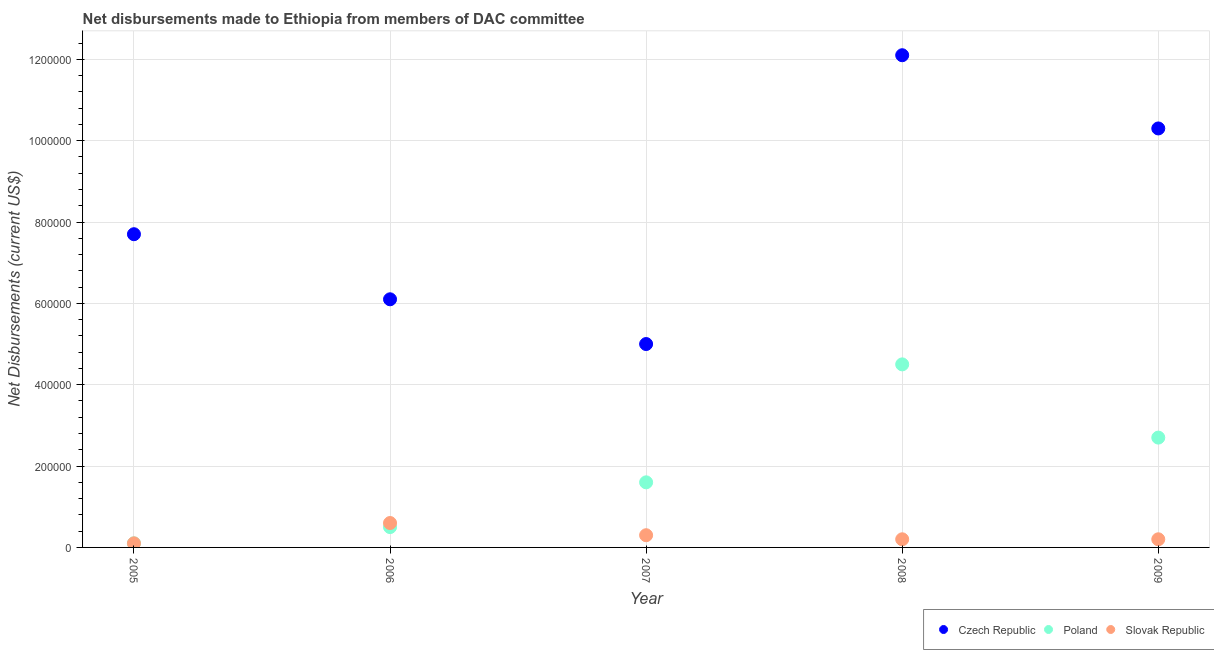What is the net disbursements made by czech republic in 2006?
Offer a very short reply. 6.10e+05. Across all years, what is the maximum net disbursements made by slovak republic?
Make the answer very short. 6.00e+04. Across all years, what is the minimum net disbursements made by slovak republic?
Offer a very short reply. 10000. In which year was the net disbursements made by poland minimum?
Provide a succinct answer. 2005. What is the total net disbursements made by poland in the graph?
Offer a terse response. 9.40e+05. What is the difference between the net disbursements made by czech republic in 2006 and that in 2007?
Provide a short and direct response. 1.10e+05. What is the difference between the net disbursements made by slovak republic in 2007 and the net disbursements made by poland in 2008?
Your response must be concise. -4.20e+05. What is the average net disbursements made by slovak republic per year?
Provide a short and direct response. 2.80e+04. In the year 2006, what is the difference between the net disbursements made by slovak republic and net disbursements made by poland?
Your answer should be very brief. 10000. What is the ratio of the net disbursements made by poland in 2007 to that in 2008?
Provide a short and direct response. 0.36. What is the difference between the highest and the second highest net disbursements made by czech republic?
Offer a terse response. 1.80e+05. What is the difference between the highest and the lowest net disbursements made by czech republic?
Offer a very short reply. 7.10e+05. How many dotlines are there?
Make the answer very short. 3. What is the difference between two consecutive major ticks on the Y-axis?
Your answer should be very brief. 2.00e+05. How many legend labels are there?
Make the answer very short. 3. What is the title of the graph?
Your response must be concise. Net disbursements made to Ethiopia from members of DAC committee. Does "Agricultural Nitrous Oxide" appear as one of the legend labels in the graph?
Keep it short and to the point. No. What is the label or title of the X-axis?
Provide a short and direct response. Year. What is the label or title of the Y-axis?
Offer a terse response. Net Disbursements (current US$). What is the Net Disbursements (current US$) of Czech Republic in 2005?
Your response must be concise. 7.70e+05. What is the Net Disbursements (current US$) of Poland in 2005?
Your response must be concise. 10000. What is the Net Disbursements (current US$) in Czech Republic in 2006?
Offer a terse response. 6.10e+05. What is the Net Disbursements (current US$) of Poland in 2006?
Provide a short and direct response. 5.00e+04. What is the Net Disbursements (current US$) in Czech Republic in 2008?
Provide a succinct answer. 1.21e+06. What is the Net Disbursements (current US$) of Czech Republic in 2009?
Your answer should be compact. 1.03e+06. What is the Net Disbursements (current US$) of Poland in 2009?
Provide a succinct answer. 2.70e+05. Across all years, what is the maximum Net Disbursements (current US$) in Czech Republic?
Your answer should be very brief. 1.21e+06. Across all years, what is the maximum Net Disbursements (current US$) in Poland?
Provide a short and direct response. 4.50e+05. Across all years, what is the maximum Net Disbursements (current US$) in Slovak Republic?
Offer a terse response. 6.00e+04. Across all years, what is the minimum Net Disbursements (current US$) of Czech Republic?
Make the answer very short. 5.00e+05. Across all years, what is the minimum Net Disbursements (current US$) of Poland?
Offer a very short reply. 10000. Across all years, what is the minimum Net Disbursements (current US$) of Slovak Republic?
Your answer should be compact. 10000. What is the total Net Disbursements (current US$) in Czech Republic in the graph?
Your answer should be compact. 4.12e+06. What is the total Net Disbursements (current US$) of Poland in the graph?
Provide a short and direct response. 9.40e+05. What is the total Net Disbursements (current US$) of Slovak Republic in the graph?
Your response must be concise. 1.40e+05. What is the difference between the Net Disbursements (current US$) of Slovak Republic in 2005 and that in 2006?
Keep it short and to the point. -5.00e+04. What is the difference between the Net Disbursements (current US$) in Czech Republic in 2005 and that in 2007?
Give a very brief answer. 2.70e+05. What is the difference between the Net Disbursements (current US$) in Poland in 2005 and that in 2007?
Make the answer very short. -1.50e+05. What is the difference between the Net Disbursements (current US$) in Slovak Republic in 2005 and that in 2007?
Make the answer very short. -2.00e+04. What is the difference between the Net Disbursements (current US$) in Czech Republic in 2005 and that in 2008?
Provide a short and direct response. -4.40e+05. What is the difference between the Net Disbursements (current US$) of Poland in 2005 and that in 2008?
Offer a terse response. -4.40e+05. What is the difference between the Net Disbursements (current US$) in Czech Republic in 2005 and that in 2009?
Offer a terse response. -2.60e+05. What is the difference between the Net Disbursements (current US$) in Poland in 2006 and that in 2007?
Provide a short and direct response. -1.10e+05. What is the difference between the Net Disbursements (current US$) of Slovak Republic in 2006 and that in 2007?
Offer a terse response. 3.00e+04. What is the difference between the Net Disbursements (current US$) of Czech Republic in 2006 and that in 2008?
Keep it short and to the point. -6.00e+05. What is the difference between the Net Disbursements (current US$) of Poland in 2006 and that in 2008?
Make the answer very short. -4.00e+05. What is the difference between the Net Disbursements (current US$) in Czech Republic in 2006 and that in 2009?
Provide a short and direct response. -4.20e+05. What is the difference between the Net Disbursements (current US$) in Poland in 2006 and that in 2009?
Make the answer very short. -2.20e+05. What is the difference between the Net Disbursements (current US$) of Czech Republic in 2007 and that in 2008?
Offer a terse response. -7.10e+05. What is the difference between the Net Disbursements (current US$) in Czech Republic in 2007 and that in 2009?
Make the answer very short. -5.30e+05. What is the difference between the Net Disbursements (current US$) of Poland in 2007 and that in 2009?
Ensure brevity in your answer.  -1.10e+05. What is the difference between the Net Disbursements (current US$) of Slovak Republic in 2007 and that in 2009?
Ensure brevity in your answer.  10000. What is the difference between the Net Disbursements (current US$) of Slovak Republic in 2008 and that in 2009?
Offer a terse response. 0. What is the difference between the Net Disbursements (current US$) in Czech Republic in 2005 and the Net Disbursements (current US$) in Poland in 2006?
Offer a terse response. 7.20e+05. What is the difference between the Net Disbursements (current US$) in Czech Republic in 2005 and the Net Disbursements (current US$) in Slovak Republic in 2006?
Give a very brief answer. 7.10e+05. What is the difference between the Net Disbursements (current US$) of Czech Republic in 2005 and the Net Disbursements (current US$) of Slovak Republic in 2007?
Provide a short and direct response. 7.40e+05. What is the difference between the Net Disbursements (current US$) of Poland in 2005 and the Net Disbursements (current US$) of Slovak Republic in 2007?
Make the answer very short. -2.00e+04. What is the difference between the Net Disbursements (current US$) of Czech Republic in 2005 and the Net Disbursements (current US$) of Poland in 2008?
Your answer should be very brief. 3.20e+05. What is the difference between the Net Disbursements (current US$) of Czech Republic in 2005 and the Net Disbursements (current US$) of Slovak Republic in 2008?
Offer a very short reply. 7.50e+05. What is the difference between the Net Disbursements (current US$) in Czech Republic in 2005 and the Net Disbursements (current US$) in Slovak Republic in 2009?
Offer a very short reply. 7.50e+05. What is the difference between the Net Disbursements (current US$) in Czech Republic in 2006 and the Net Disbursements (current US$) in Poland in 2007?
Make the answer very short. 4.50e+05. What is the difference between the Net Disbursements (current US$) of Czech Republic in 2006 and the Net Disbursements (current US$) of Slovak Republic in 2007?
Provide a succinct answer. 5.80e+05. What is the difference between the Net Disbursements (current US$) of Poland in 2006 and the Net Disbursements (current US$) of Slovak Republic in 2007?
Your answer should be very brief. 2.00e+04. What is the difference between the Net Disbursements (current US$) of Czech Republic in 2006 and the Net Disbursements (current US$) of Poland in 2008?
Offer a terse response. 1.60e+05. What is the difference between the Net Disbursements (current US$) of Czech Republic in 2006 and the Net Disbursements (current US$) of Slovak Republic in 2008?
Offer a terse response. 5.90e+05. What is the difference between the Net Disbursements (current US$) in Czech Republic in 2006 and the Net Disbursements (current US$) in Slovak Republic in 2009?
Your answer should be compact. 5.90e+05. What is the difference between the Net Disbursements (current US$) in Poland in 2006 and the Net Disbursements (current US$) in Slovak Republic in 2009?
Your answer should be compact. 3.00e+04. What is the difference between the Net Disbursements (current US$) of Czech Republic in 2007 and the Net Disbursements (current US$) of Slovak Republic in 2008?
Keep it short and to the point. 4.80e+05. What is the difference between the Net Disbursements (current US$) of Czech Republic in 2007 and the Net Disbursements (current US$) of Poland in 2009?
Your response must be concise. 2.30e+05. What is the difference between the Net Disbursements (current US$) of Czech Republic in 2008 and the Net Disbursements (current US$) of Poland in 2009?
Make the answer very short. 9.40e+05. What is the difference between the Net Disbursements (current US$) of Czech Republic in 2008 and the Net Disbursements (current US$) of Slovak Republic in 2009?
Provide a short and direct response. 1.19e+06. What is the average Net Disbursements (current US$) of Czech Republic per year?
Provide a succinct answer. 8.24e+05. What is the average Net Disbursements (current US$) of Poland per year?
Offer a very short reply. 1.88e+05. What is the average Net Disbursements (current US$) of Slovak Republic per year?
Keep it short and to the point. 2.80e+04. In the year 2005, what is the difference between the Net Disbursements (current US$) of Czech Republic and Net Disbursements (current US$) of Poland?
Your answer should be very brief. 7.60e+05. In the year 2005, what is the difference between the Net Disbursements (current US$) of Czech Republic and Net Disbursements (current US$) of Slovak Republic?
Keep it short and to the point. 7.60e+05. In the year 2006, what is the difference between the Net Disbursements (current US$) in Czech Republic and Net Disbursements (current US$) in Poland?
Provide a succinct answer. 5.60e+05. In the year 2006, what is the difference between the Net Disbursements (current US$) of Poland and Net Disbursements (current US$) of Slovak Republic?
Ensure brevity in your answer.  -10000. In the year 2008, what is the difference between the Net Disbursements (current US$) of Czech Republic and Net Disbursements (current US$) of Poland?
Provide a succinct answer. 7.60e+05. In the year 2008, what is the difference between the Net Disbursements (current US$) in Czech Republic and Net Disbursements (current US$) in Slovak Republic?
Ensure brevity in your answer.  1.19e+06. In the year 2008, what is the difference between the Net Disbursements (current US$) of Poland and Net Disbursements (current US$) of Slovak Republic?
Make the answer very short. 4.30e+05. In the year 2009, what is the difference between the Net Disbursements (current US$) in Czech Republic and Net Disbursements (current US$) in Poland?
Give a very brief answer. 7.60e+05. In the year 2009, what is the difference between the Net Disbursements (current US$) of Czech Republic and Net Disbursements (current US$) of Slovak Republic?
Your response must be concise. 1.01e+06. In the year 2009, what is the difference between the Net Disbursements (current US$) in Poland and Net Disbursements (current US$) in Slovak Republic?
Provide a succinct answer. 2.50e+05. What is the ratio of the Net Disbursements (current US$) in Czech Republic in 2005 to that in 2006?
Offer a terse response. 1.26. What is the ratio of the Net Disbursements (current US$) of Poland in 2005 to that in 2006?
Give a very brief answer. 0.2. What is the ratio of the Net Disbursements (current US$) of Czech Republic in 2005 to that in 2007?
Give a very brief answer. 1.54. What is the ratio of the Net Disbursements (current US$) in Poland in 2005 to that in 2007?
Ensure brevity in your answer.  0.06. What is the ratio of the Net Disbursements (current US$) in Czech Republic in 2005 to that in 2008?
Give a very brief answer. 0.64. What is the ratio of the Net Disbursements (current US$) in Poland in 2005 to that in 2008?
Your answer should be very brief. 0.02. What is the ratio of the Net Disbursements (current US$) in Czech Republic in 2005 to that in 2009?
Offer a terse response. 0.75. What is the ratio of the Net Disbursements (current US$) of Poland in 2005 to that in 2009?
Your response must be concise. 0.04. What is the ratio of the Net Disbursements (current US$) of Czech Republic in 2006 to that in 2007?
Make the answer very short. 1.22. What is the ratio of the Net Disbursements (current US$) in Poland in 2006 to that in 2007?
Your answer should be compact. 0.31. What is the ratio of the Net Disbursements (current US$) of Slovak Republic in 2006 to that in 2007?
Your answer should be compact. 2. What is the ratio of the Net Disbursements (current US$) of Czech Republic in 2006 to that in 2008?
Give a very brief answer. 0.5. What is the ratio of the Net Disbursements (current US$) in Poland in 2006 to that in 2008?
Your answer should be compact. 0.11. What is the ratio of the Net Disbursements (current US$) in Czech Republic in 2006 to that in 2009?
Provide a short and direct response. 0.59. What is the ratio of the Net Disbursements (current US$) in Poland in 2006 to that in 2009?
Provide a short and direct response. 0.19. What is the ratio of the Net Disbursements (current US$) in Czech Republic in 2007 to that in 2008?
Keep it short and to the point. 0.41. What is the ratio of the Net Disbursements (current US$) of Poland in 2007 to that in 2008?
Offer a terse response. 0.36. What is the ratio of the Net Disbursements (current US$) of Slovak Republic in 2007 to that in 2008?
Keep it short and to the point. 1.5. What is the ratio of the Net Disbursements (current US$) of Czech Republic in 2007 to that in 2009?
Your response must be concise. 0.49. What is the ratio of the Net Disbursements (current US$) in Poland in 2007 to that in 2009?
Offer a terse response. 0.59. What is the ratio of the Net Disbursements (current US$) in Czech Republic in 2008 to that in 2009?
Ensure brevity in your answer.  1.17. What is the ratio of the Net Disbursements (current US$) in Poland in 2008 to that in 2009?
Make the answer very short. 1.67. What is the ratio of the Net Disbursements (current US$) of Slovak Republic in 2008 to that in 2009?
Ensure brevity in your answer.  1. What is the difference between the highest and the second highest Net Disbursements (current US$) in Czech Republic?
Your response must be concise. 1.80e+05. What is the difference between the highest and the second highest Net Disbursements (current US$) of Slovak Republic?
Provide a succinct answer. 3.00e+04. What is the difference between the highest and the lowest Net Disbursements (current US$) of Czech Republic?
Provide a short and direct response. 7.10e+05. What is the difference between the highest and the lowest Net Disbursements (current US$) in Poland?
Give a very brief answer. 4.40e+05. 